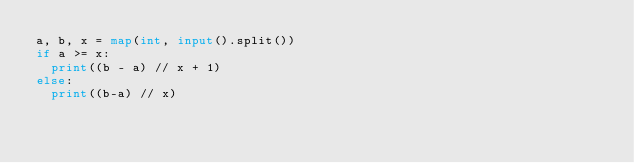Convert code to text. <code><loc_0><loc_0><loc_500><loc_500><_Python_>a, b, x = map(int, input().split())
if a >= x:
  print((b - a) // x + 1)
else:
  print((b-a) // x)</code> 